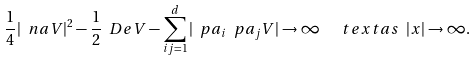Convert formula to latex. <formula><loc_0><loc_0><loc_500><loc_500>\frac { 1 } { 4 } | \ n a V | ^ { 2 } - \frac { 1 } { 2 } \ D e V - \sum _ { i j = 1 } ^ { d } | \ p a _ { i } \ p a _ { j } V | \to \infty \ \ \ t e x t { a s } \ | x | \to \infty .</formula> 